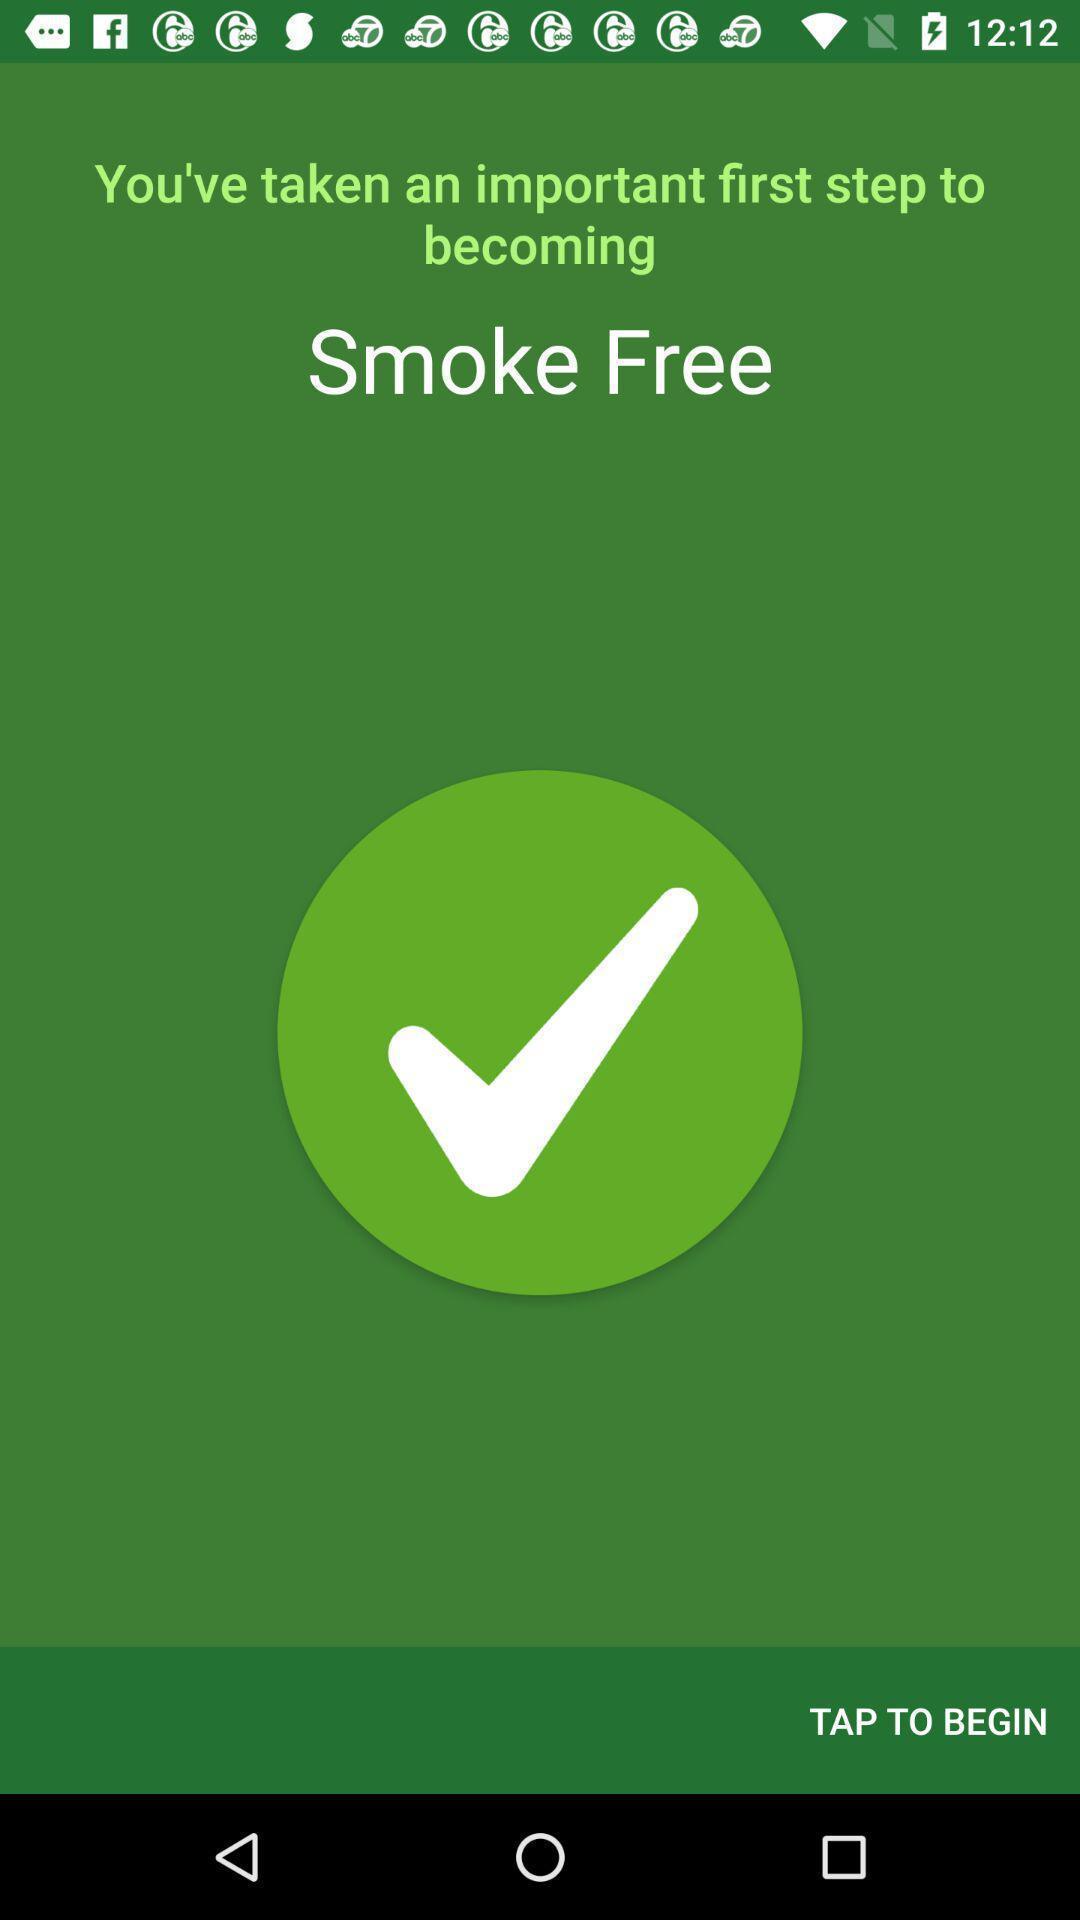Describe the key features of this screenshot. Welcome page for a smoke tracking app. 